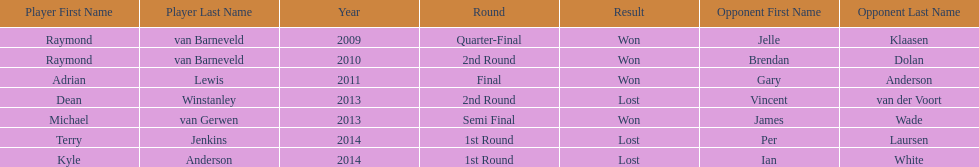How many champions were from norway? 0. 